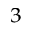Convert formula to latex. <formula><loc_0><loc_0><loc_500><loc_500>^ { 3 }</formula> 